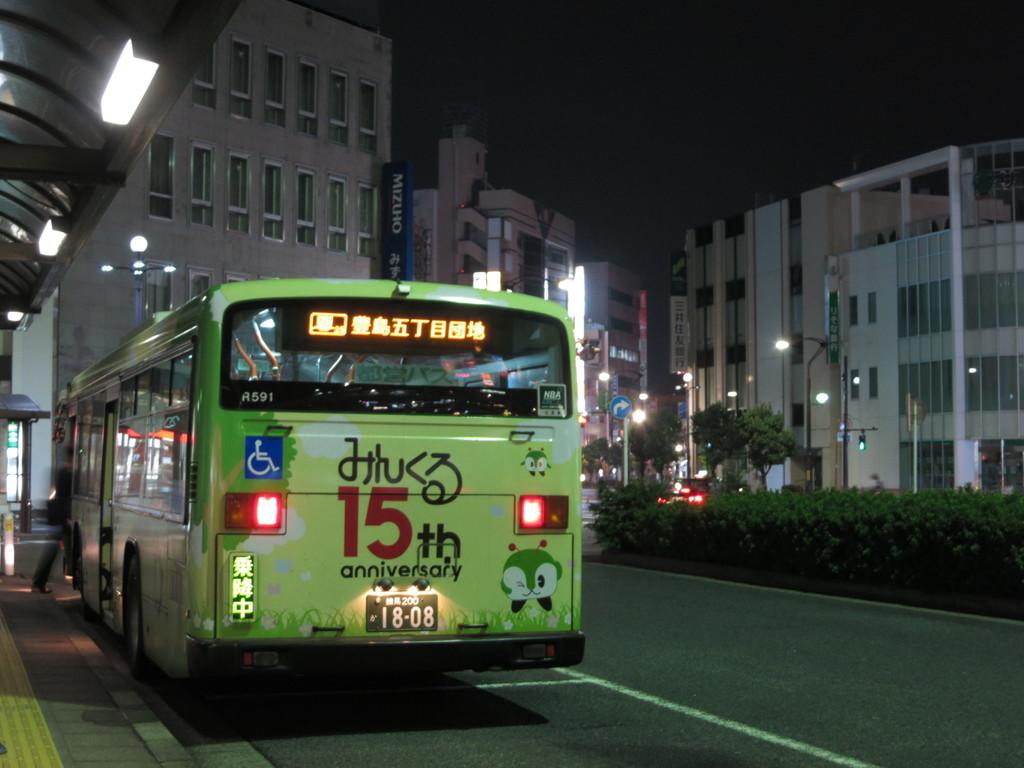What bus number is the green bus?
Offer a very short reply. R591. What anniversary is it?
Keep it short and to the point. 15th. 